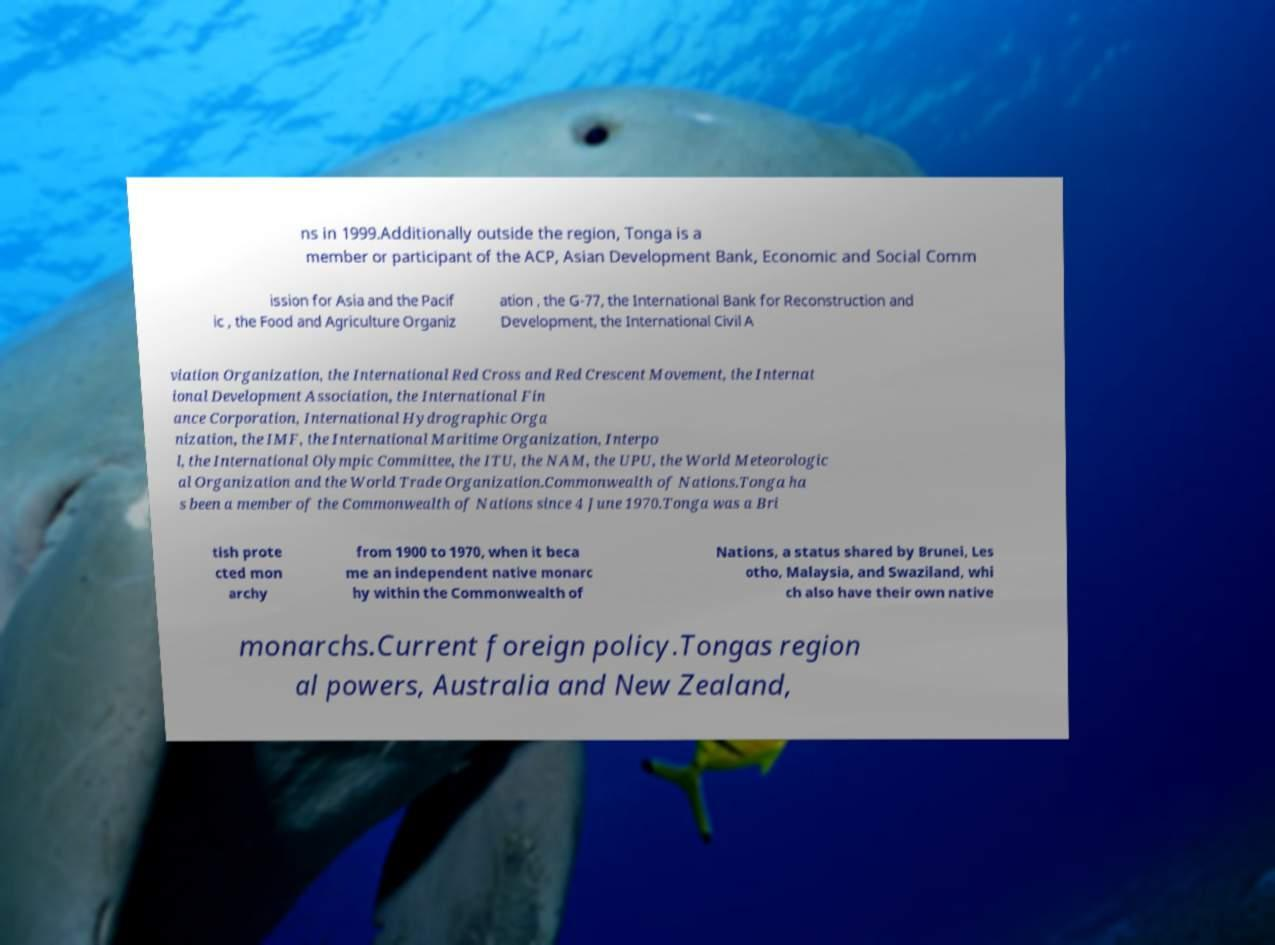What messages or text are displayed in this image? I need them in a readable, typed format. ns in 1999.Additionally outside the region, Tonga is a member or participant of the ACP, Asian Development Bank, Economic and Social Comm ission for Asia and the Pacif ic , the Food and Agriculture Organiz ation , the G-77, the International Bank for Reconstruction and Development, the International Civil A viation Organization, the International Red Cross and Red Crescent Movement, the Internat ional Development Association, the International Fin ance Corporation, International Hydrographic Orga nization, the IMF, the International Maritime Organization, Interpo l, the International Olympic Committee, the ITU, the NAM, the UPU, the World Meteorologic al Organization and the World Trade Organization.Commonwealth of Nations.Tonga ha s been a member of the Commonwealth of Nations since 4 June 1970.Tonga was a Bri tish prote cted mon archy from 1900 to 1970, when it beca me an independent native monarc hy within the Commonwealth of Nations, a status shared by Brunei, Les otho, Malaysia, and Swaziland, whi ch also have their own native monarchs.Current foreign policy.Tongas region al powers, Australia and New Zealand, 